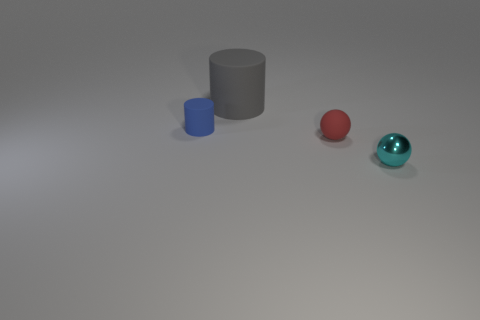Add 2 big gray rubber cylinders. How many objects exist? 6 Add 2 small spheres. How many small spheres exist? 4 Subtract 0 green balls. How many objects are left? 4 Subtract all large gray things. Subtract all purple spheres. How many objects are left? 3 Add 1 shiny things. How many shiny things are left? 2 